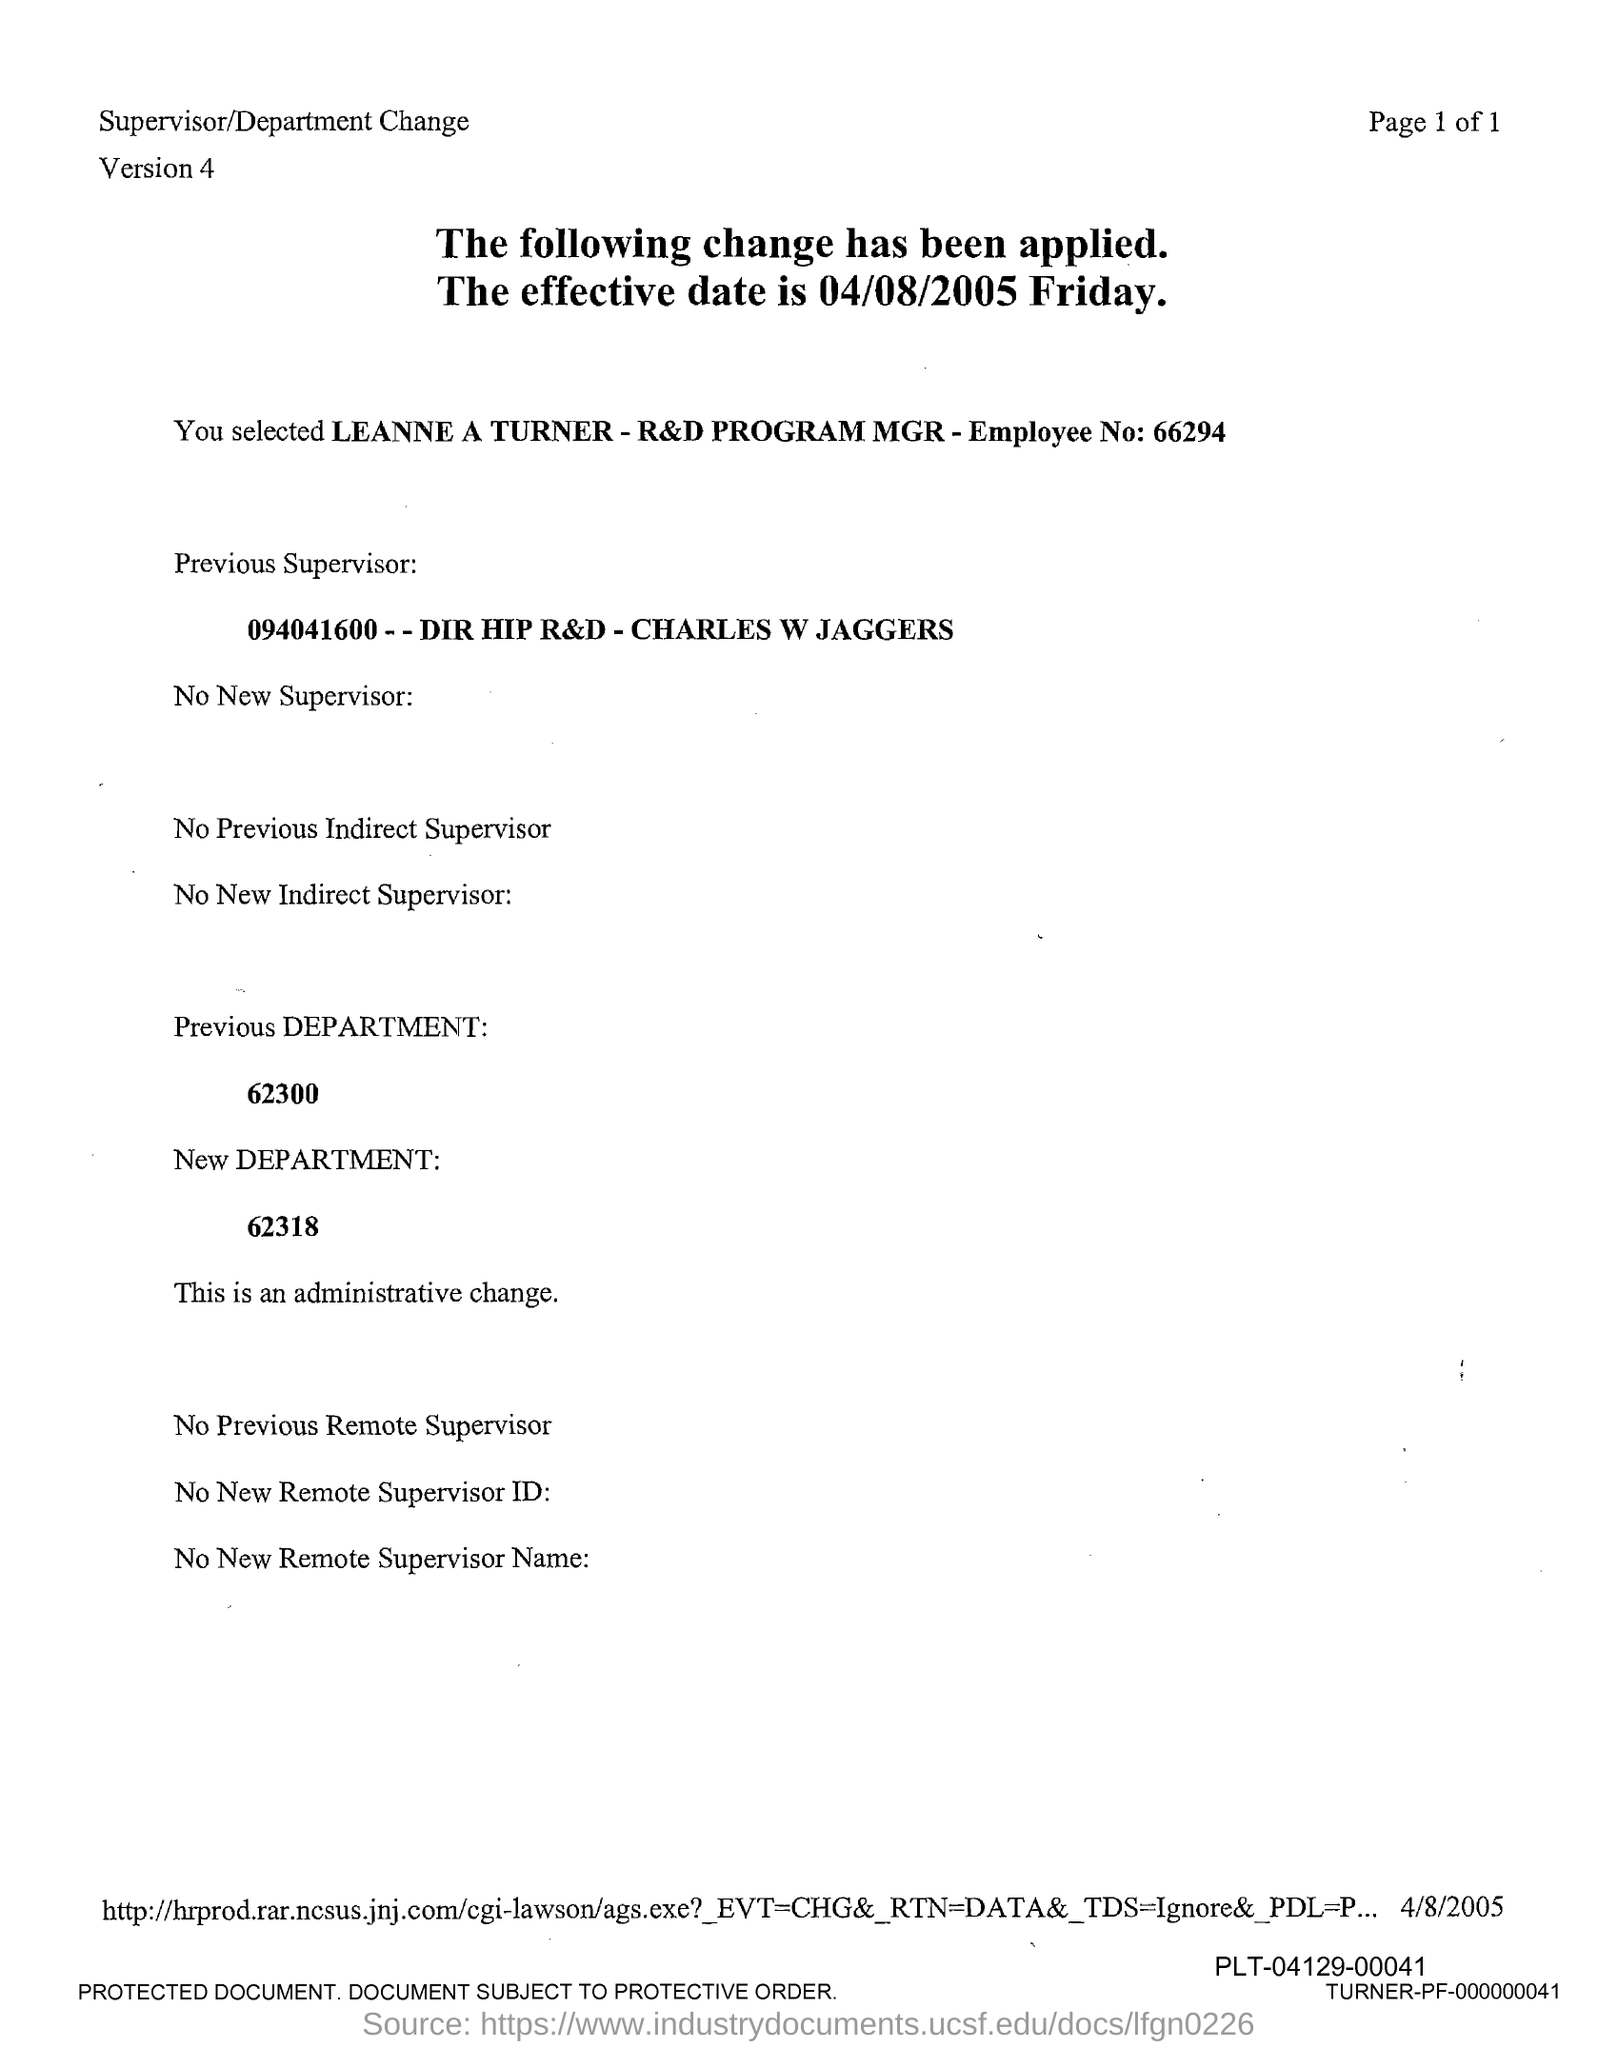Indicate a few pertinent items in this graphic. The version mentioned in the document is 4. The new department number is 62318. The previous department number is 62300. The employee number is 66294... 